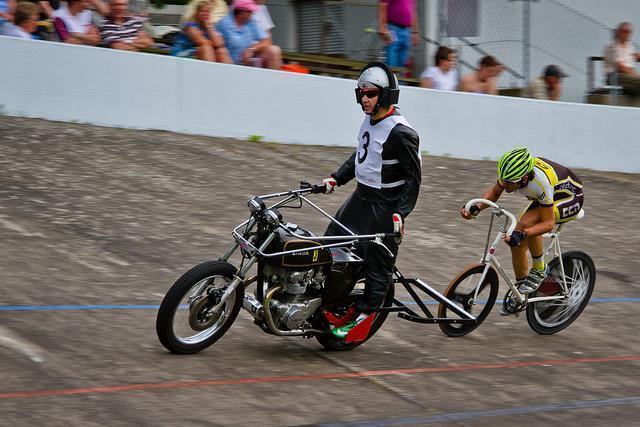How many bikes are in the photo?
Give a very brief answer. 2. How many people are there?
Give a very brief answer. 6. How many refrigerators are there?
Give a very brief answer. 0. 